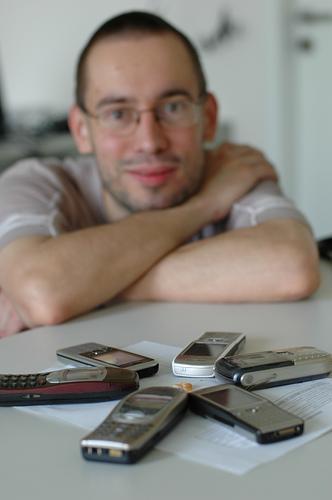How many cell phones?
Give a very brief answer. 6. How many people?
Give a very brief answer. 1. How many pieces of paper?
Give a very brief answer. 1. 